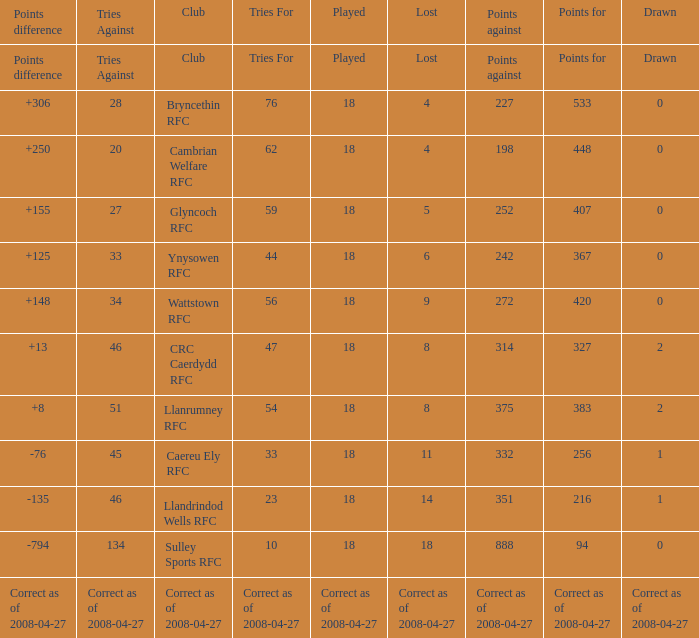What is the value for the item "Lost" when the value "Tries" is 47? 8.0. 